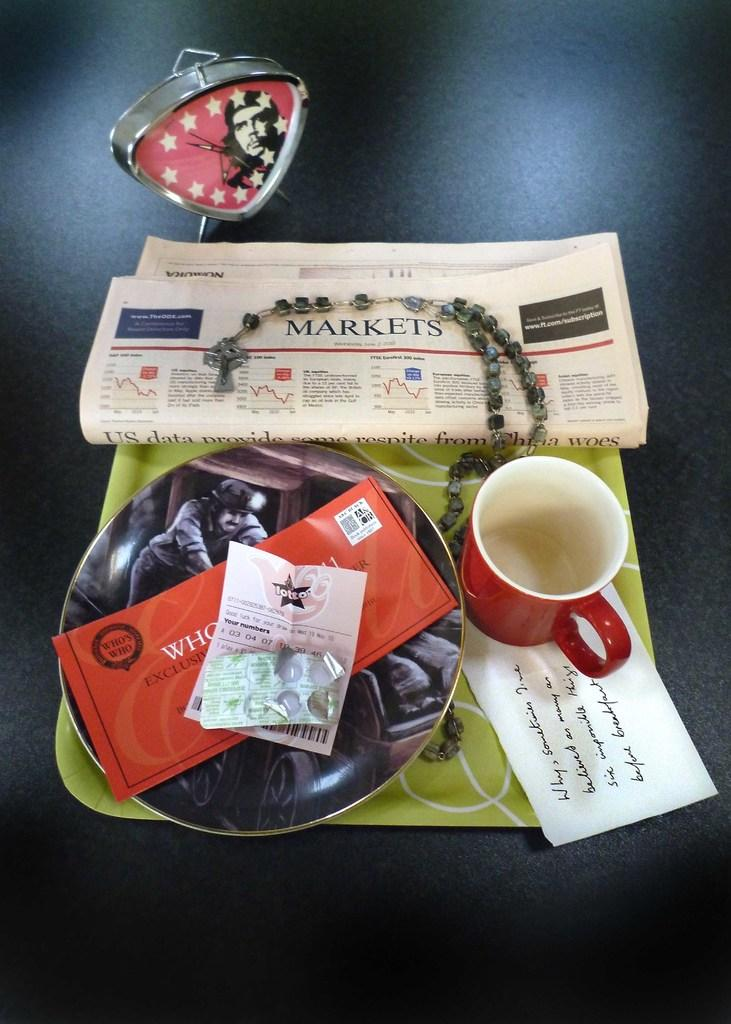<image>
Write a terse but informative summary of the picture. A tray with dishes and a newspaper showing the Markets page on it. 